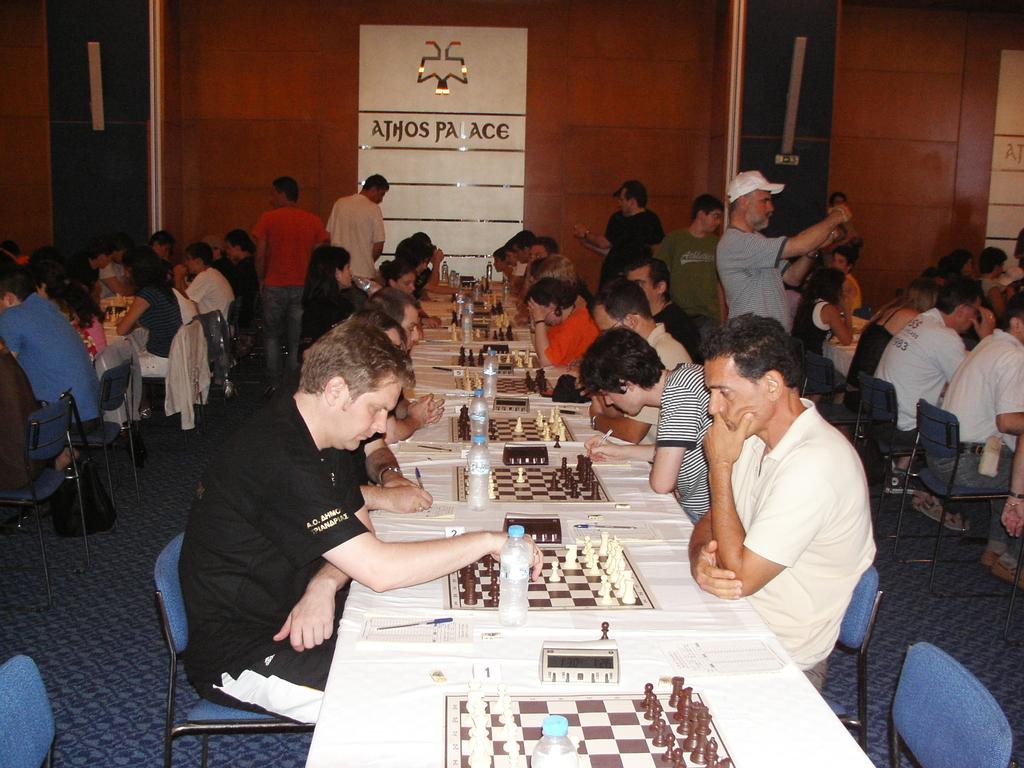What are the people in the image doing? The people in the image are sitting on chairs and standing. What objects are present in the image that might be used for seating? There are chairs and tables in the image. What activity might the people be engaged in, given the presence of chess boards on the tables? The people might be playing chess, as chess boards are present on the tables. What else can be seen on the tables besides the chess boards? There are bottles visible on the tables. What type of glass is being used to play chess in the image? There is no glass present in the image, and chess is played on a chess board, not with glass. 